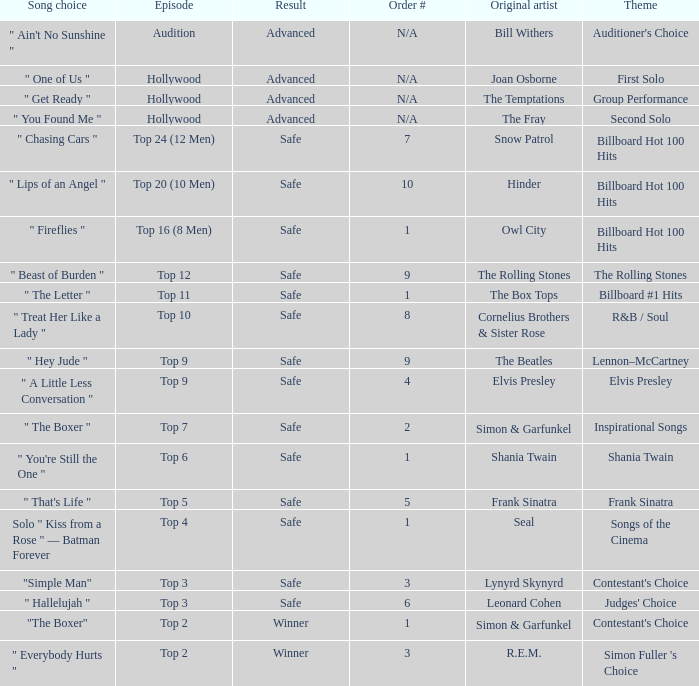In which episode is the order number 10? Top 20 (10 Men). 